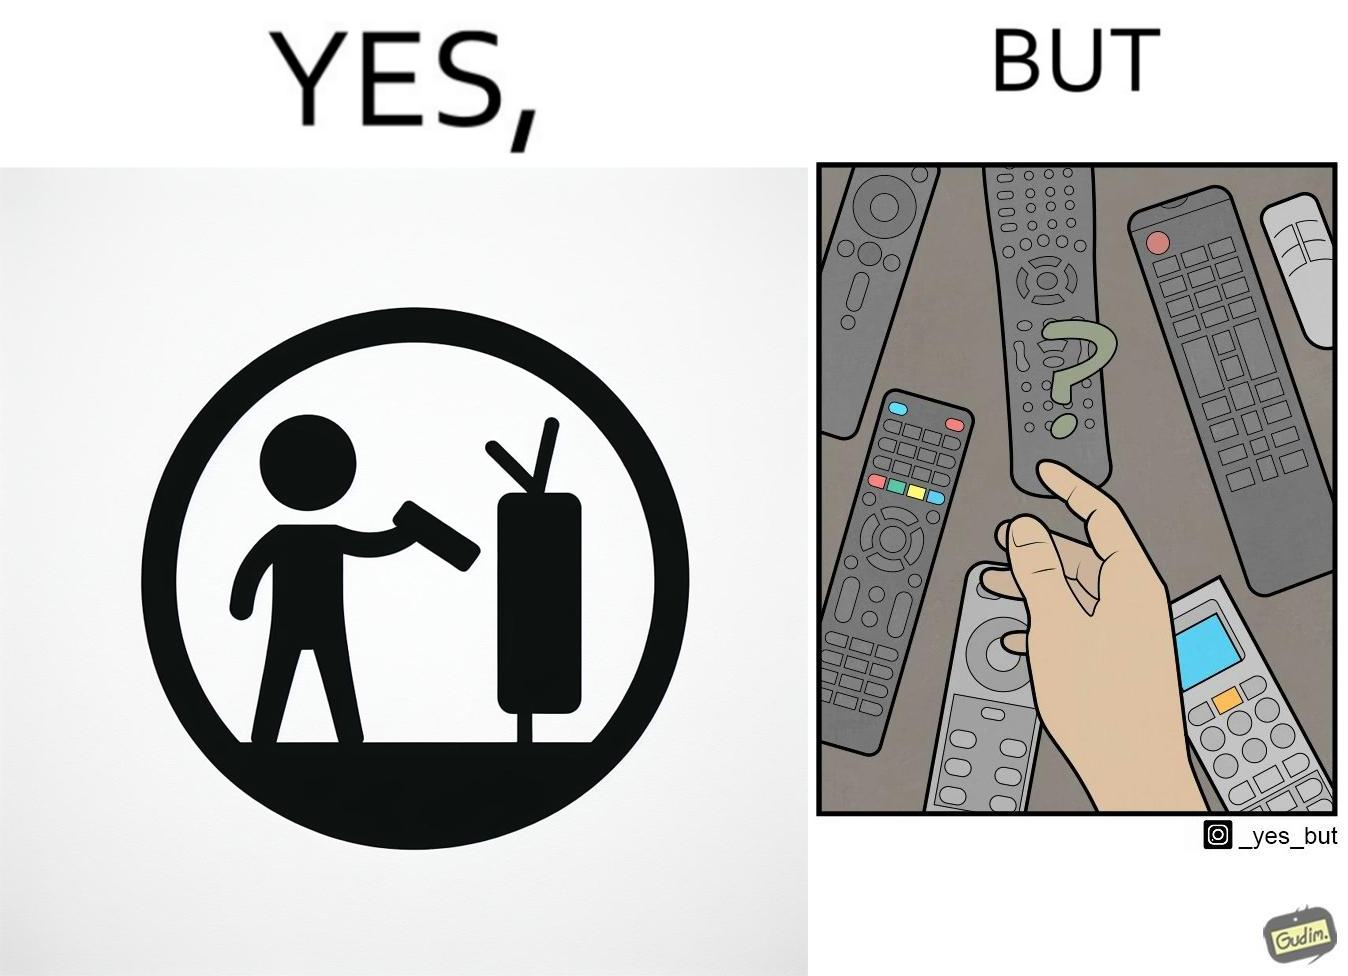Describe what you see in the left and right parts of this image. In the left part of the image: It is a remote being used to operate a TV In the right part of the image: It is an user confused between multiple remotes 